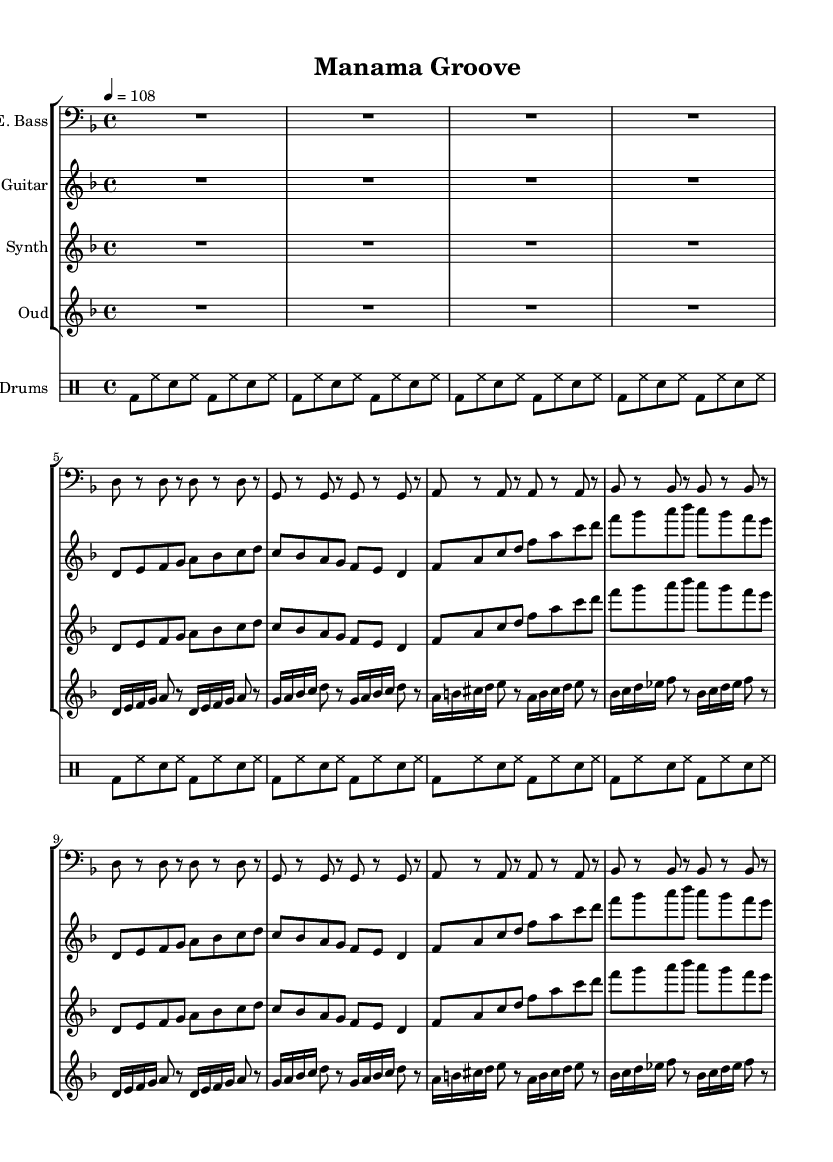What is the key signature of this music? The key signature indicates D minor, which has one flat (B flat). This can be deduced from the key signature visually placed at the beginning of the staff.
Answer: D minor What is the time signature of this music? The time signature is 4/4, meaning there are four beats per measure, and each quarter note gets one beat. This is indicated numerically at the beginning of the sheet music.
Answer: 4/4 What is the tempo marking of this music? The tempo marking is Allegro, indicated by the numerical value "108" which means 108 beats per minute. This information is located right after the time signature in the header area.
Answer: 108 How many measures are repeated in the electric guitar part? The electric guitar part shows a repetition of two measures denoted by the "repeat unfold 2" notation, indicating that the section should be played twice.
Answer: 2 What instrument plays the main theme? The main theme is played by both the electric guitar and the synthesizer, as indicated by the respective parts labeled for these instruments in the score.
Answer: Electric guitar and synthesizer Which percussion elements are predominantly used in the drum part? The drum part primarily features the bass drum (bd), snare drum (sn), and hi-hat (hh), depicted visually in the drummode section for clarity on the percussion rhythm.
Answer: Bass drum, snare drum, hi-hat Which Middle Eastern instrument is featured in this composition? The oud is the Middle Eastern instrument featured in the arrangement, and it is specifically indicated with its own staff labeled "Oud."
Answer: Oud 